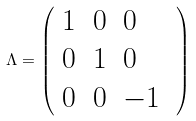<formula> <loc_0><loc_0><loc_500><loc_500>\Lambda = \left ( \begin{array} { l l l } 1 & 0 & 0 \\ 0 & 1 & 0 \\ 0 & 0 & - 1 \end{array} \text { } \right )</formula> 